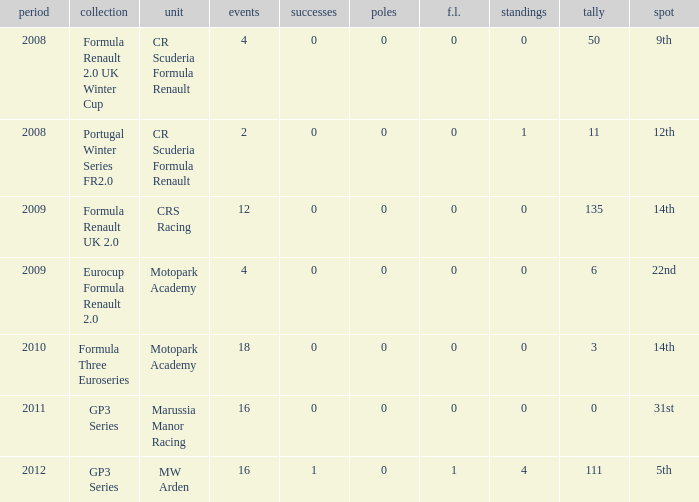What are the most poles listed? 0.0. 